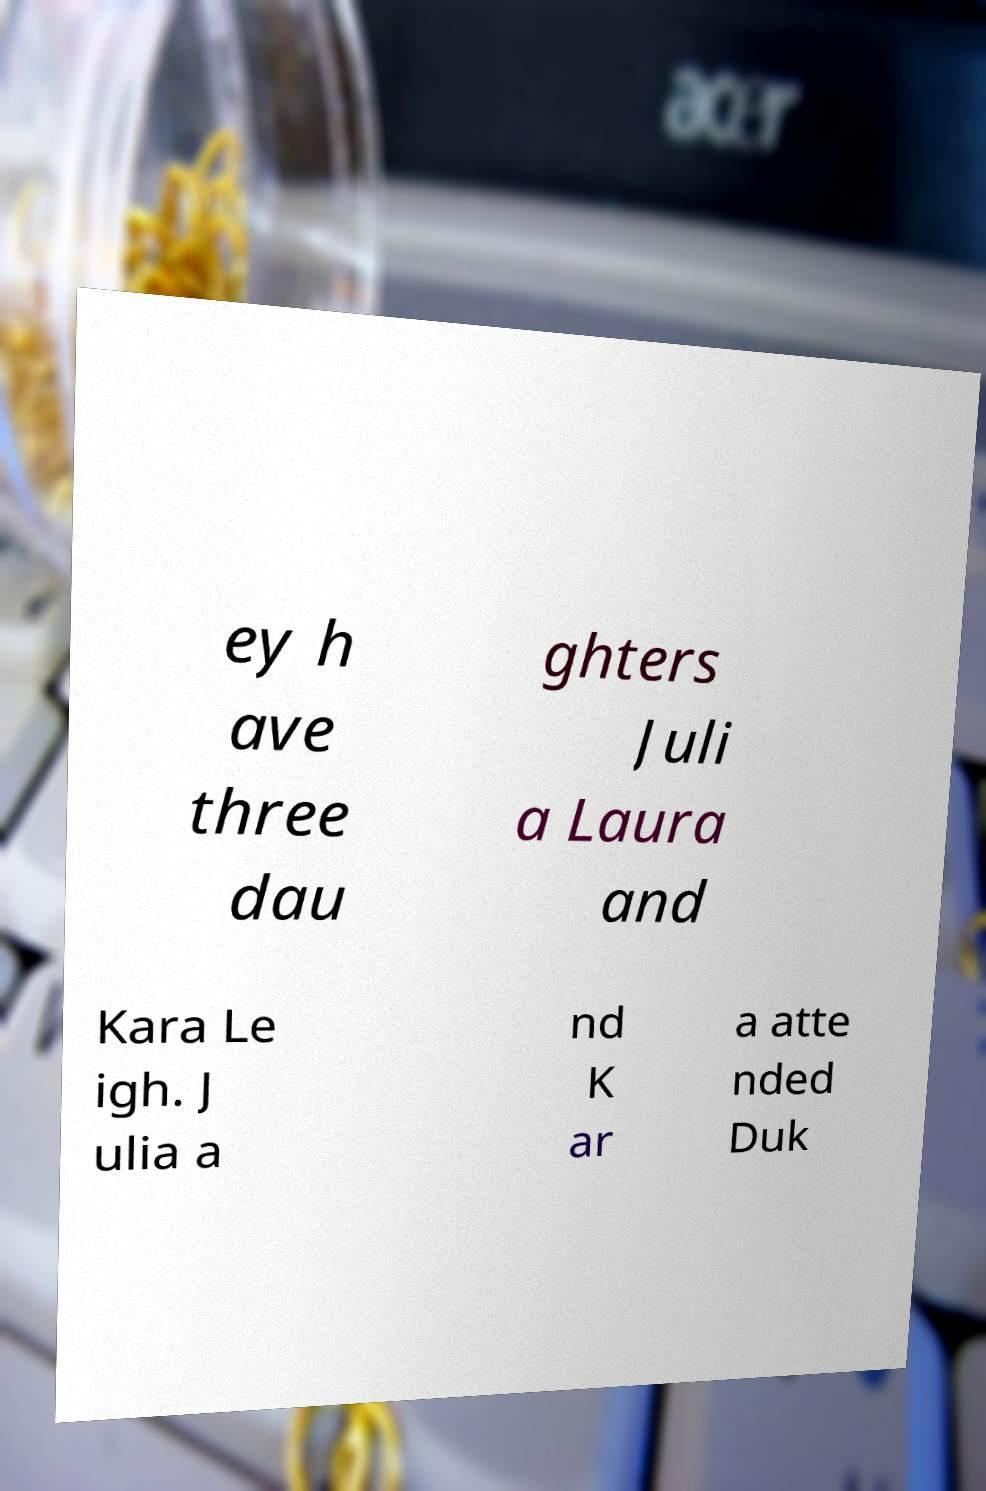Can you read and provide the text displayed in the image?This photo seems to have some interesting text. Can you extract and type it out for me? ey h ave three dau ghters Juli a Laura and Kara Le igh. J ulia a nd K ar a atte nded Duk 